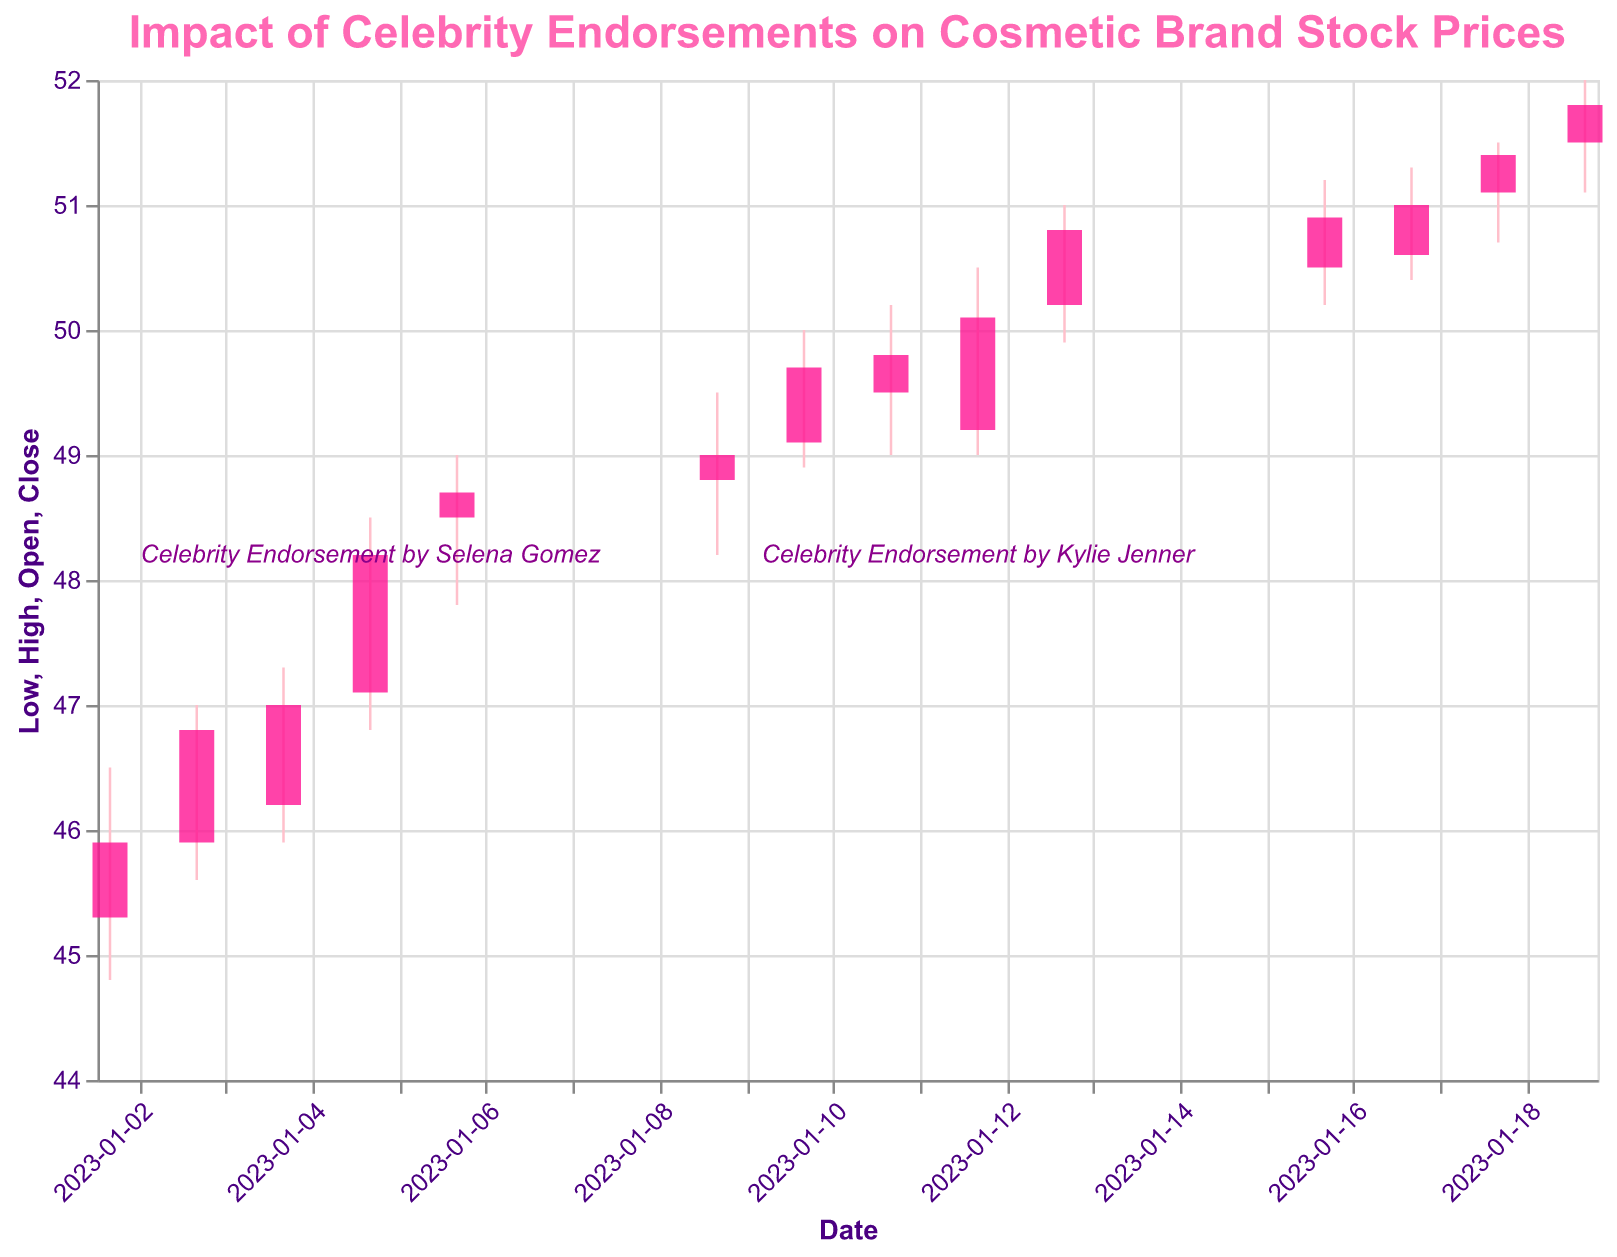What is the title of the figure? The title of the figure is usually located at the top and describes the content of the plot. Here, it is "Impact of Celebrity Endorsements on Cosmetic Brand Stock Prices," which indicates the figure shows how celebrity endorsements influence stock prices of a cosmetic brand.
Answer: Impact of Celebrity Endorsements on Cosmetic Brand Stock Prices On which dates did celebrity endorsements occur? The figure includes labels for specific dates when celebrity endorsements happened. By observing the plot, we can see endorsements on January 5th and January 12th.
Answer: January 5th and January 12th How did the stock price change on the day of Selena Gomez's endorsement? Selena Gomez's endorsement happened on January 5th. Checking the stock's high and low on that day, the price opened at 47.10, reached a high of 48.50, dipped to a low of 46.80, and closed at 48.20.
Answer: The stock price rose; it opened at 47.10 and closed at 48.20 Compare the highest stock prices on the days of the endorsements by Selena Gomez and Kylie Jenner. Which had a higher impact? The highest price on January 5th (Selena Gomez's endorsement) was 48.50, and for January 12th (Kylie Jenner's endorsement), it was 50.50. Comparing these, Kylie Jenner's endorsement had a higher peak impact.
Answer: Kylie Jenner's endorsement What was the stock price trend in the week following Selena Gomez's endorsement? After January 5th, look at January 6th, 9th, 10th, 11th, and 12th to notice the price movements. The stock opened higher each subsequent day and generally trended upward, closing on January 12th at 50.10.
Answer: The trend was upward What is the difference in closing prices between January 2nd and January 19th? To find the difference between the closing prices on January 2nd (45.90) and January 19th (51.80), we subtract the former from the latter, i.e., 51.80 - 45.90.
Answer: 5.90 Which date saw the highest trading volume, and what is the volume? Checking the volume values for all dates, January 19th recorded the highest volume at 1,500,000 shares.
Answer: January 19th, 1,500,000 What is the average closing price between January 2nd and January 19th? Sum the closing prices over the given dates and divide by the number of days: (45.90 + 46.80 + 47.00 + 48.20 + 48.70 + 49.00 + 49.70 + 49.50 + 50.10 + 50.80 + 50.50 + 51.00 + 51.40 + 51.80) / 14.
Answer: 49.39 How does the closing price on January 13th compare to January 17th? Comparing the closing prices, January 13th closed at 50.80, while January 17th closed at 51.00. January 17th had a higher closing price.
Answer: January 17th higher 